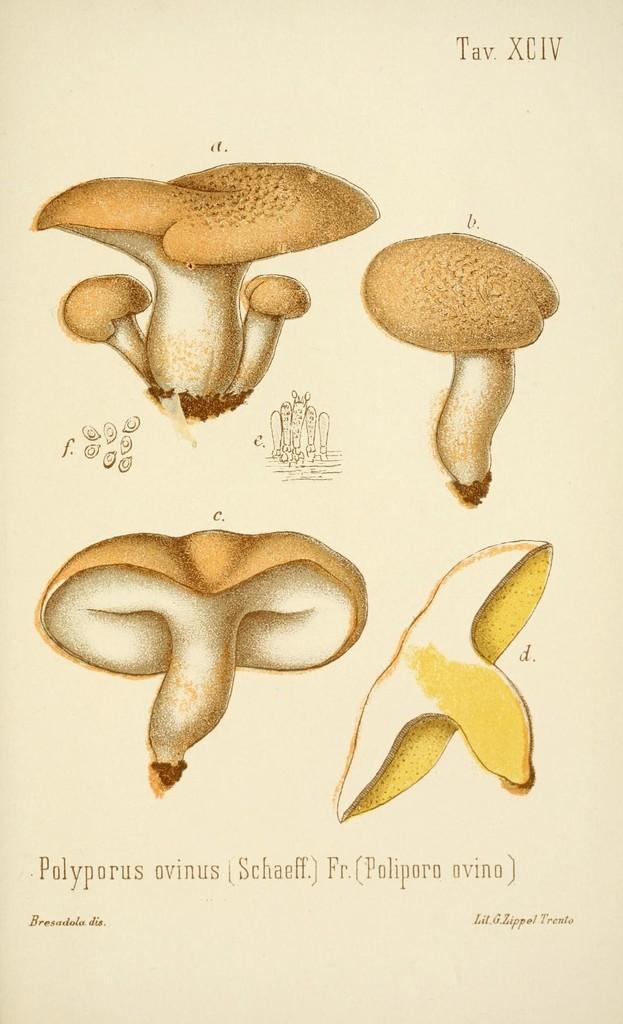In one or two sentences, can you explain what this image depicts? In this image I can see few pictures of the mushrooms and I can see the cream color background. 